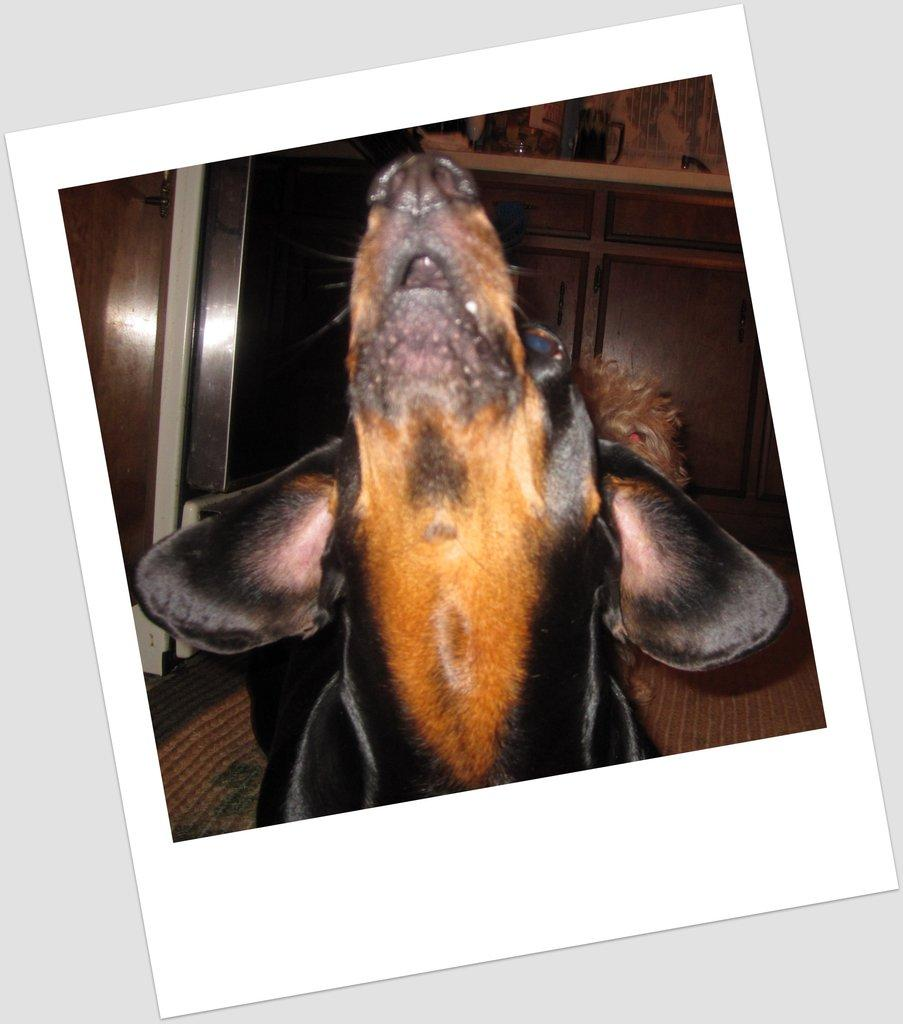What is the main subject of the image? The main subject of the image is a photograph of a dog's face. Can you describe the background of the image? In the background of the image, there are cupboards. How many servants are visible in the image? There are no servants present in the image; it features a photograph of a dog's face and cupboards in the background. What type of fold can be seen in the dog's fur in the image? There is no fold visible in the dog's fur in the image, as it is a photograph of the dog's face and does not show the dog's entire body. 